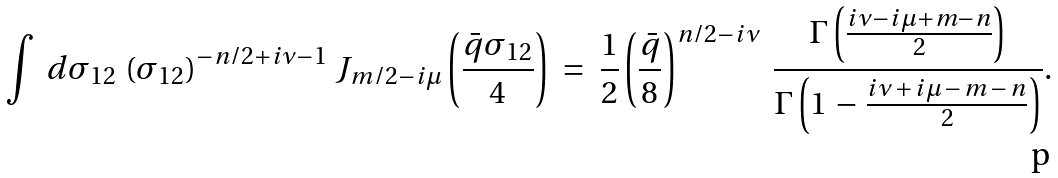<formula> <loc_0><loc_0><loc_500><loc_500>\int \ d \sigma _ { 1 2 } \ ( \sigma _ { 1 2 } ) ^ { - n / 2 + i \nu - 1 } \ J _ { m / 2 - i \mu } \left ( \frac { \bar { q } \sigma _ { 1 2 } } 4 \right ) \ = \ \frac { 1 } { 2 } \left ( \frac { \bar { q } } 8 \right ) ^ { n / 2 - i \nu } \ \frac { \Gamma \left ( \frac { i \nu - i \mu + m - n } 2 \right ) } { \Gamma \left ( 1 \, - \, \frac { i \nu \, + \, i \mu \, - \, m \, - \, n } 2 \right ) } .</formula> 